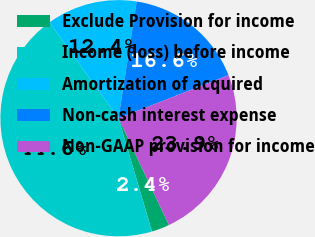Convert chart to OTSL. <chart><loc_0><loc_0><loc_500><loc_500><pie_chart><fcel>Exclude Provision for income<fcel>Income (loss) before income<fcel>Amortization of acquired<fcel>Non-cash interest expense<fcel>Non-GAAP provision for income<nl><fcel>2.44%<fcel>44.65%<fcel>12.39%<fcel>16.61%<fcel>23.92%<nl></chart> 